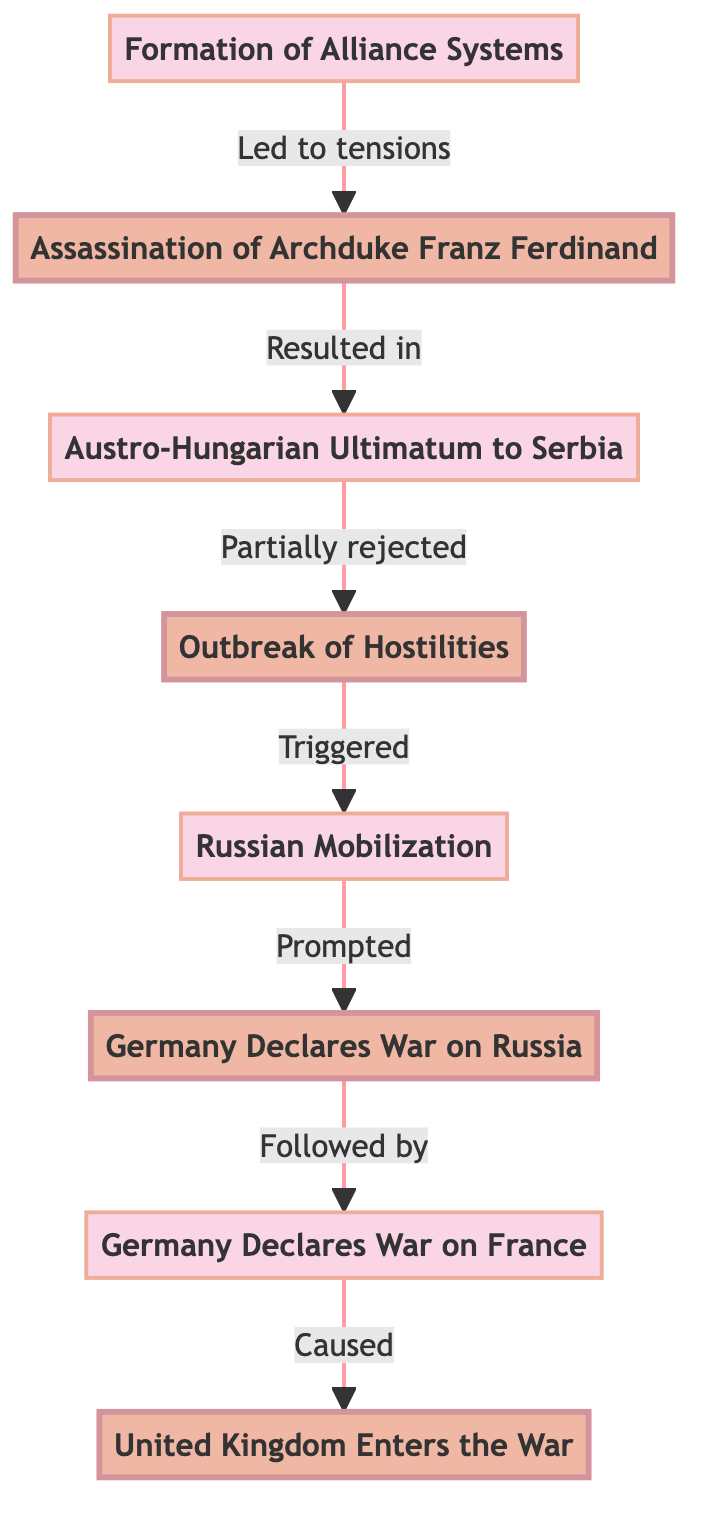What event led to the tensions between nations? The flow chart indicates that the "Formation of Alliance Systems" led to tensions. This is depicted as the starting point of the chart, clearly linking to the subsequent assassination event.
Answer: Formation of Alliance Systems On what date was Archduke Franz Ferdinand assassinated? The diagram highlights that the assassination took place on June 28, 1914. This specific date is directly linked to the event in the flow chart.
Answer: June 28, 1914 What was the result of the assassination of Franz Ferdinand? According to the flow chart, the assassination resulted in the "Austro-Hungarian Ultimatum to Serbia," which directly follows the assassination in the sequence of events.
Answer: Austro-Hungarian Ultimatum to Serbia How many main events are indicated in the flowchart? The flowchart presents four main events: the assassination, outbreak of hostilities, Germany declaring war on Russia, and the United Kingdom entering the war. Counting these from the diagram, we find there are 4 main events.
Answer: 4 What triggered Russian mobilization? The flow chart indicates that the "Outbreak of Hostilities" triggered Russian mobilization. This can be deduced by following the arrows from the outbreak to the subsequent mobilization.
Answer: Outbreak of Hostilities Which event caused the United Kingdom to enter the war? The diagram shows that the "Germany Declares War on France" caused the United Kingdom to enter the war. This is indicated by the sequence of events leading to the UK's declaration of war.
Answer: Germany Declares War on France What relationship is indicated between Serbia and the Austro-Hungarian Ultimatum? The flowchart specifies that Serbia's partial rejection of the ultimatum led to the outbreak of hostilities, illustrating a direct cause-and-effect relationship between these two events.
Answer: Partially rejected What event follows Russia's mobilization in the flowchart? Following Russia's mobilization, the next event is "Germany Declares War on Russia," which is shown directly after mobilization in the sequence of events.
Answer: Germany Declares War on Russia What event marks the beginning of hostilities according to the chart? The chart marks the "Outbreak of Hostilities" as the event that begins actual conflict between nations, following the ultimatum and Serbia's response.
Answer: Outbreak of Hostilities 